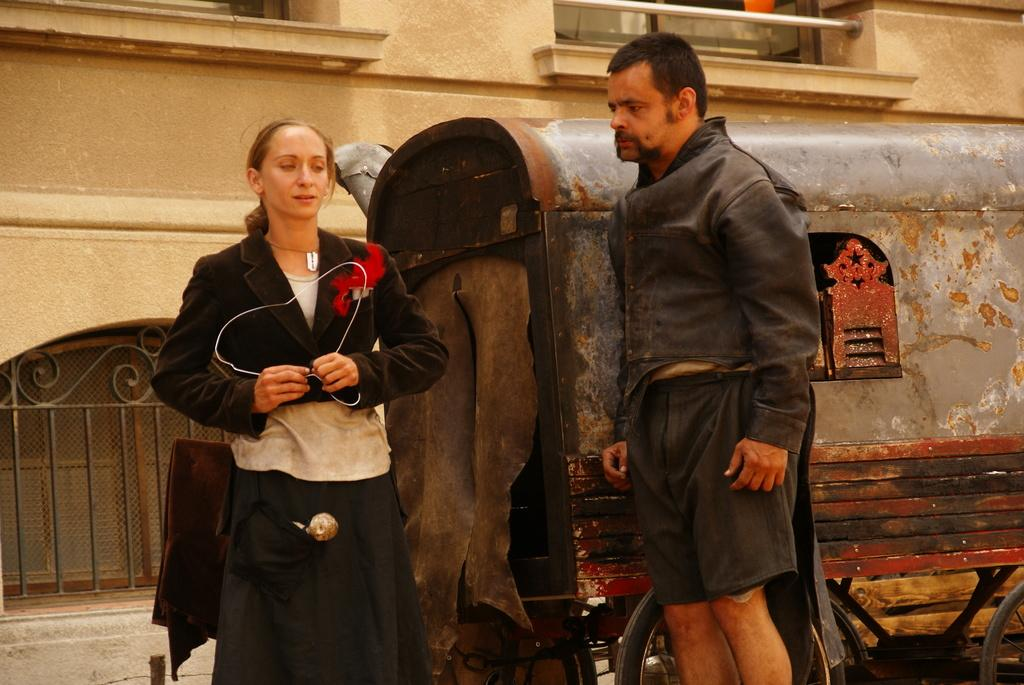What can be seen in the image? There are persons standing in the image. What are the persons wearing? The persons are wearing clothes. What is located in the middle of the image? There is a vehicle in the middle of the image. What architectural feature is present in the image? There are windows on the wall in the image. Where is the desk located in the image? There is no desk present in the image. What color are the toes of the persons in the image? There is no indication of the color of the persons' toes in the image. 